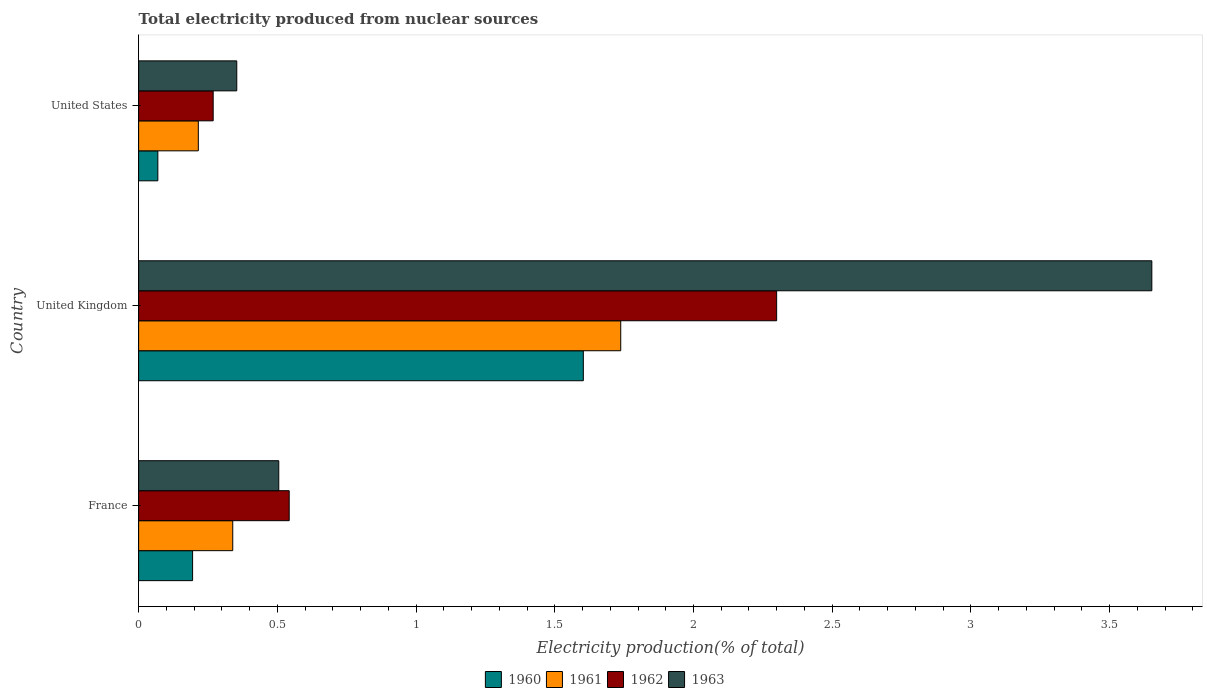How many different coloured bars are there?
Ensure brevity in your answer.  4. How many groups of bars are there?
Ensure brevity in your answer.  3. Are the number of bars per tick equal to the number of legend labels?
Keep it short and to the point. Yes. In how many cases, is the number of bars for a given country not equal to the number of legend labels?
Keep it short and to the point. 0. What is the total electricity produced in 1961 in United States?
Your answer should be compact. 0.22. Across all countries, what is the maximum total electricity produced in 1962?
Make the answer very short. 2.3. Across all countries, what is the minimum total electricity produced in 1963?
Ensure brevity in your answer.  0.35. In which country was the total electricity produced in 1962 maximum?
Your response must be concise. United Kingdom. In which country was the total electricity produced in 1963 minimum?
Give a very brief answer. United States. What is the total total electricity produced in 1960 in the graph?
Your response must be concise. 1.87. What is the difference between the total electricity produced in 1963 in France and that in United Kingdom?
Offer a very short reply. -3.15. What is the difference between the total electricity produced in 1962 in United States and the total electricity produced in 1963 in United Kingdom?
Your answer should be very brief. -3.38. What is the average total electricity produced in 1962 per country?
Ensure brevity in your answer.  1.04. What is the difference between the total electricity produced in 1963 and total electricity produced in 1960 in United Kingdom?
Offer a very short reply. 2.05. What is the ratio of the total electricity produced in 1962 in France to that in United Kingdom?
Offer a very short reply. 0.24. What is the difference between the highest and the second highest total electricity produced in 1961?
Your answer should be very brief. 1.4. What is the difference between the highest and the lowest total electricity produced in 1961?
Your response must be concise. 1.52. What does the 2nd bar from the top in United Kingdom represents?
Keep it short and to the point. 1962. Is it the case that in every country, the sum of the total electricity produced in 1961 and total electricity produced in 1960 is greater than the total electricity produced in 1962?
Ensure brevity in your answer.  No. Are all the bars in the graph horizontal?
Offer a terse response. Yes. How many countries are there in the graph?
Your answer should be compact. 3. What is the difference between two consecutive major ticks on the X-axis?
Offer a terse response. 0.5. Does the graph contain any zero values?
Give a very brief answer. No. Does the graph contain grids?
Ensure brevity in your answer.  No. Where does the legend appear in the graph?
Your answer should be very brief. Bottom center. How are the legend labels stacked?
Make the answer very short. Horizontal. What is the title of the graph?
Your response must be concise. Total electricity produced from nuclear sources. What is the Electricity production(% of total) in 1960 in France?
Give a very brief answer. 0.19. What is the Electricity production(% of total) in 1961 in France?
Give a very brief answer. 0.34. What is the Electricity production(% of total) of 1962 in France?
Give a very brief answer. 0.54. What is the Electricity production(% of total) in 1963 in France?
Provide a short and direct response. 0.51. What is the Electricity production(% of total) in 1960 in United Kingdom?
Keep it short and to the point. 1.6. What is the Electricity production(% of total) in 1961 in United Kingdom?
Provide a short and direct response. 1.74. What is the Electricity production(% of total) in 1962 in United Kingdom?
Offer a terse response. 2.3. What is the Electricity production(% of total) of 1963 in United Kingdom?
Your answer should be very brief. 3.65. What is the Electricity production(% of total) in 1960 in United States?
Offer a very short reply. 0.07. What is the Electricity production(% of total) in 1961 in United States?
Keep it short and to the point. 0.22. What is the Electricity production(% of total) in 1962 in United States?
Ensure brevity in your answer.  0.27. What is the Electricity production(% of total) of 1963 in United States?
Offer a terse response. 0.35. Across all countries, what is the maximum Electricity production(% of total) in 1960?
Ensure brevity in your answer.  1.6. Across all countries, what is the maximum Electricity production(% of total) of 1961?
Your answer should be compact. 1.74. Across all countries, what is the maximum Electricity production(% of total) in 1962?
Offer a terse response. 2.3. Across all countries, what is the maximum Electricity production(% of total) in 1963?
Provide a succinct answer. 3.65. Across all countries, what is the minimum Electricity production(% of total) of 1960?
Provide a short and direct response. 0.07. Across all countries, what is the minimum Electricity production(% of total) in 1961?
Give a very brief answer. 0.22. Across all countries, what is the minimum Electricity production(% of total) of 1962?
Keep it short and to the point. 0.27. Across all countries, what is the minimum Electricity production(% of total) of 1963?
Your response must be concise. 0.35. What is the total Electricity production(% of total) in 1960 in the graph?
Provide a short and direct response. 1.87. What is the total Electricity production(% of total) of 1961 in the graph?
Offer a terse response. 2.29. What is the total Electricity production(% of total) of 1962 in the graph?
Provide a short and direct response. 3.11. What is the total Electricity production(% of total) of 1963 in the graph?
Keep it short and to the point. 4.51. What is the difference between the Electricity production(% of total) in 1960 in France and that in United Kingdom?
Your answer should be very brief. -1.41. What is the difference between the Electricity production(% of total) in 1961 in France and that in United Kingdom?
Offer a terse response. -1.4. What is the difference between the Electricity production(% of total) in 1962 in France and that in United Kingdom?
Your answer should be compact. -1.76. What is the difference between the Electricity production(% of total) of 1963 in France and that in United Kingdom?
Your answer should be very brief. -3.15. What is the difference between the Electricity production(% of total) in 1960 in France and that in United States?
Give a very brief answer. 0.13. What is the difference between the Electricity production(% of total) of 1961 in France and that in United States?
Your response must be concise. 0.12. What is the difference between the Electricity production(% of total) of 1962 in France and that in United States?
Ensure brevity in your answer.  0.27. What is the difference between the Electricity production(% of total) of 1963 in France and that in United States?
Ensure brevity in your answer.  0.15. What is the difference between the Electricity production(% of total) of 1960 in United Kingdom and that in United States?
Provide a succinct answer. 1.53. What is the difference between the Electricity production(% of total) in 1961 in United Kingdom and that in United States?
Provide a short and direct response. 1.52. What is the difference between the Electricity production(% of total) in 1962 in United Kingdom and that in United States?
Provide a succinct answer. 2.03. What is the difference between the Electricity production(% of total) in 1963 in United Kingdom and that in United States?
Your answer should be compact. 3.3. What is the difference between the Electricity production(% of total) of 1960 in France and the Electricity production(% of total) of 1961 in United Kingdom?
Make the answer very short. -1.54. What is the difference between the Electricity production(% of total) in 1960 in France and the Electricity production(% of total) in 1962 in United Kingdom?
Give a very brief answer. -2.11. What is the difference between the Electricity production(% of total) of 1960 in France and the Electricity production(% of total) of 1963 in United Kingdom?
Your answer should be compact. -3.46. What is the difference between the Electricity production(% of total) of 1961 in France and the Electricity production(% of total) of 1962 in United Kingdom?
Ensure brevity in your answer.  -1.96. What is the difference between the Electricity production(% of total) in 1961 in France and the Electricity production(% of total) in 1963 in United Kingdom?
Keep it short and to the point. -3.31. What is the difference between the Electricity production(% of total) in 1962 in France and the Electricity production(% of total) in 1963 in United Kingdom?
Offer a terse response. -3.11. What is the difference between the Electricity production(% of total) of 1960 in France and the Electricity production(% of total) of 1961 in United States?
Keep it short and to the point. -0.02. What is the difference between the Electricity production(% of total) in 1960 in France and the Electricity production(% of total) in 1962 in United States?
Ensure brevity in your answer.  -0.07. What is the difference between the Electricity production(% of total) in 1960 in France and the Electricity production(% of total) in 1963 in United States?
Keep it short and to the point. -0.16. What is the difference between the Electricity production(% of total) of 1961 in France and the Electricity production(% of total) of 1962 in United States?
Your answer should be compact. 0.07. What is the difference between the Electricity production(% of total) in 1961 in France and the Electricity production(% of total) in 1963 in United States?
Make the answer very short. -0.01. What is the difference between the Electricity production(% of total) in 1962 in France and the Electricity production(% of total) in 1963 in United States?
Ensure brevity in your answer.  0.19. What is the difference between the Electricity production(% of total) in 1960 in United Kingdom and the Electricity production(% of total) in 1961 in United States?
Your answer should be compact. 1.39. What is the difference between the Electricity production(% of total) in 1960 in United Kingdom and the Electricity production(% of total) in 1962 in United States?
Ensure brevity in your answer.  1.33. What is the difference between the Electricity production(% of total) of 1960 in United Kingdom and the Electricity production(% of total) of 1963 in United States?
Your answer should be compact. 1.25. What is the difference between the Electricity production(% of total) of 1961 in United Kingdom and the Electricity production(% of total) of 1962 in United States?
Offer a terse response. 1.47. What is the difference between the Electricity production(% of total) in 1961 in United Kingdom and the Electricity production(% of total) in 1963 in United States?
Keep it short and to the point. 1.38. What is the difference between the Electricity production(% of total) in 1962 in United Kingdom and the Electricity production(% of total) in 1963 in United States?
Keep it short and to the point. 1.95. What is the average Electricity production(% of total) of 1960 per country?
Provide a succinct answer. 0.62. What is the average Electricity production(% of total) of 1961 per country?
Your response must be concise. 0.76. What is the average Electricity production(% of total) of 1963 per country?
Make the answer very short. 1.5. What is the difference between the Electricity production(% of total) in 1960 and Electricity production(% of total) in 1961 in France?
Ensure brevity in your answer.  -0.14. What is the difference between the Electricity production(% of total) of 1960 and Electricity production(% of total) of 1962 in France?
Offer a terse response. -0.35. What is the difference between the Electricity production(% of total) in 1960 and Electricity production(% of total) in 1963 in France?
Offer a terse response. -0.31. What is the difference between the Electricity production(% of total) in 1961 and Electricity production(% of total) in 1962 in France?
Give a very brief answer. -0.2. What is the difference between the Electricity production(% of total) of 1961 and Electricity production(% of total) of 1963 in France?
Your response must be concise. -0.17. What is the difference between the Electricity production(% of total) in 1962 and Electricity production(% of total) in 1963 in France?
Provide a succinct answer. 0.04. What is the difference between the Electricity production(% of total) in 1960 and Electricity production(% of total) in 1961 in United Kingdom?
Your response must be concise. -0.13. What is the difference between the Electricity production(% of total) of 1960 and Electricity production(% of total) of 1962 in United Kingdom?
Make the answer very short. -0.7. What is the difference between the Electricity production(% of total) of 1960 and Electricity production(% of total) of 1963 in United Kingdom?
Give a very brief answer. -2.05. What is the difference between the Electricity production(% of total) in 1961 and Electricity production(% of total) in 1962 in United Kingdom?
Ensure brevity in your answer.  -0.56. What is the difference between the Electricity production(% of total) in 1961 and Electricity production(% of total) in 1963 in United Kingdom?
Make the answer very short. -1.91. What is the difference between the Electricity production(% of total) in 1962 and Electricity production(% of total) in 1963 in United Kingdom?
Give a very brief answer. -1.35. What is the difference between the Electricity production(% of total) of 1960 and Electricity production(% of total) of 1961 in United States?
Provide a succinct answer. -0.15. What is the difference between the Electricity production(% of total) in 1960 and Electricity production(% of total) in 1962 in United States?
Offer a very short reply. -0.2. What is the difference between the Electricity production(% of total) of 1960 and Electricity production(% of total) of 1963 in United States?
Make the answer very short. -0.28. What is the difference between the Electricity production(% of total) in 1961 and Electricity production(% of total) in 1962 in United States?
Your response must be concise. -0.05. What is the difference between the Electricity production(% of total) of 1961 and Electricity production(% of total) of 1963 in United States?
Your answer should be compact. -0.14. What is the difference between the Electricity production(% of total) of 1962 and Electricity production(% of total) of 1963 in United States?
Your answer should be compact. -0.09. What is the ratio of the Electricity production(% of total) of 1960 in France to that in United Kingdom?
Your answer should be compact. 0.12. What is the ratio of the Electricity production(% of total) in 1961 in France to that in United Kingdom?
Ensure brevity in your answer.  0.2. What is the ratio of the Electricity production(% of total) in 1962 in France to that in United Kingdom?
Your response must be concise. 0.24. What is the ratio of the Electricity production(% of total) of 1963 in France to that in United Kingdom?
Offer a terse response. 0.14. What is the ratio of the Electricity production(% of total) in 1960 in France to that in United States?
Your response must be concise. 2.81. What is the ratio of the Electricity production(% of total) in 1961 in France to that in United States?
Keep it short and to the point. 1.58. What is the ratio of the Electricity production(% of total) in 1962 in France to that in United States?
Provide a succinct answer. 2.02. What is the ratio of the Electricity production(% of total) in 1963 in France to that in United States?
Offer a terse response. 1.43. What is the ratio of the Electricity production(% of total) in 1960 in United Kingdom to that in United States?
Your answer should be compact. 23.14. What is the ratio of the Electricity production(% of total) of 1961 in United Kingdom to that in United States?
Give a very brief answer. 8.08. What is the ratio of the Electricity production(% of total) in 1962 in United Kingdom to that in United States?
Offer a terse response. 8.56. What is the ratio of the Electricity production(% of total) in 1963 in United Kingdom to that in United States?
Make the answer very short. 10.32. What is the difference between the highest and the second highest Electricity production(% of total) of 1960?
Provide a succinct answer. 1.41. What is the difference between the highest and the second highest Electricity production(% of total) of 1961?
Make the answer very short. 1.4. What is the difference between the highest and the second highest Electricity production(% of total) in 1962?
Your answer should be very brief. 1.76. What is the difference between the highest and the second highest Electricity production(% of total) in 1963?
Your answer should be compact. 3.15. What is the difference between the highest and the lowest Electricity production(% of total) in 1960?
Your response must be concise. 1.53. What is the difference between the highest and the lowest Electricity production(% of total) of 1961?
Make the answer very short. 1.52. What is the difference between the highest and the lowest Electricity production(% of total) in 1962?
Make the answer very short. 2.03. What is the difference between the highest and the lowest Electricity production(% of total) in 1963?
Keep it short and to the point. 3.3. 